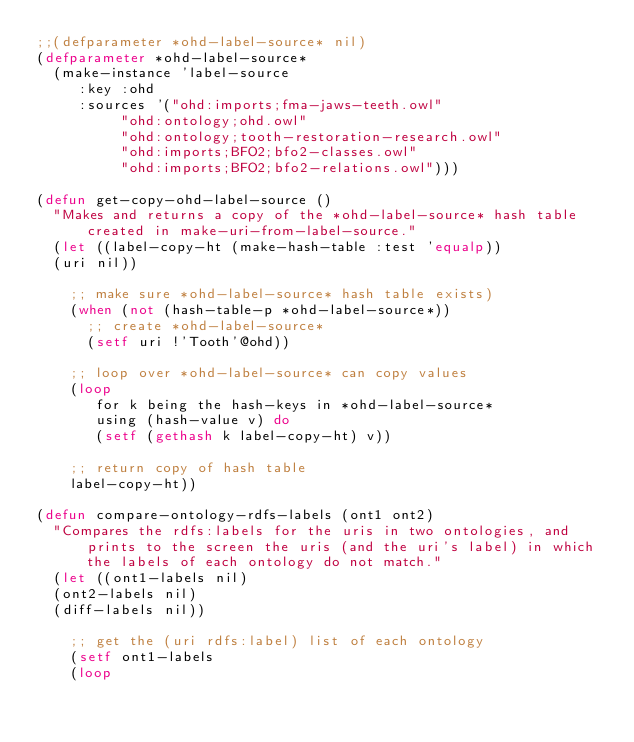Convert code to text. <code><loc_0><loc_0><loc_500><loc_500><_Lisp_>;;(defparameter *ohd-label-source* nil)
(defparameter *ohd-label-source*
  (make-instance 'label-source
		 :key :ohd
		 :sources '("ohd:imports;fma-jaws-teeth.owl"
			    "ohd:ontology;ohd.owl"
			    "ohd:ontology;tooth-restoration-research.owl"
			    "ohd:imports;BFO2;bfo2-classes.owl"
			    "ohd:imports;BFO2;bfo2-relations.owl")))

(defun get-copy-ohd-label-source ()
  "Makes and returns a copy of the *ohd-label-source* hash table created in make-uri-from-label-source."
  (let ((label-copy-ht (make-hash-table :test 'equalp))
	(uri nil))
  
    ;; make sure *ohd-label-source* hash table exists)
    (when (not (hash-table-p *ohd-label-source*))
      ;; create *ohd-label-source*
      (setf uri !'Tooth'@ohd))

    ;; loop over *ohd-label-source* can copy values
    (loop 
       for k being the hash-keys in *ohd-label-source*
       using (hash-value v) do
       (setf (gethash k label-copy-ht) v))

    ;; return copy of hash table
    label-copy-ht))

(defun compare-ontology-rdfs-labels (ont1 ont2)
  "Compares the rdfs:labels for the uris in two ontologies, and prints to the screen the uris (and the uri's label) in which the labels of each ontology do not match."
  (let ((ont1-labels nil)
	(ont2-labels nil)
	(diff-labels nil))

    ;; get the (uri rdfs:label) list of each ontology
    (setf ont1-labels 
	  (loop </code> 